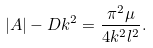<formula> <loc_0><loc_0><loc_500><loc_500>\left | A \right | - D k ^ { 2 } = \frac { \pi ^ { 2 } \mu } { 4 k ^ { 2 } l ^ { 2 } } .</formula> 